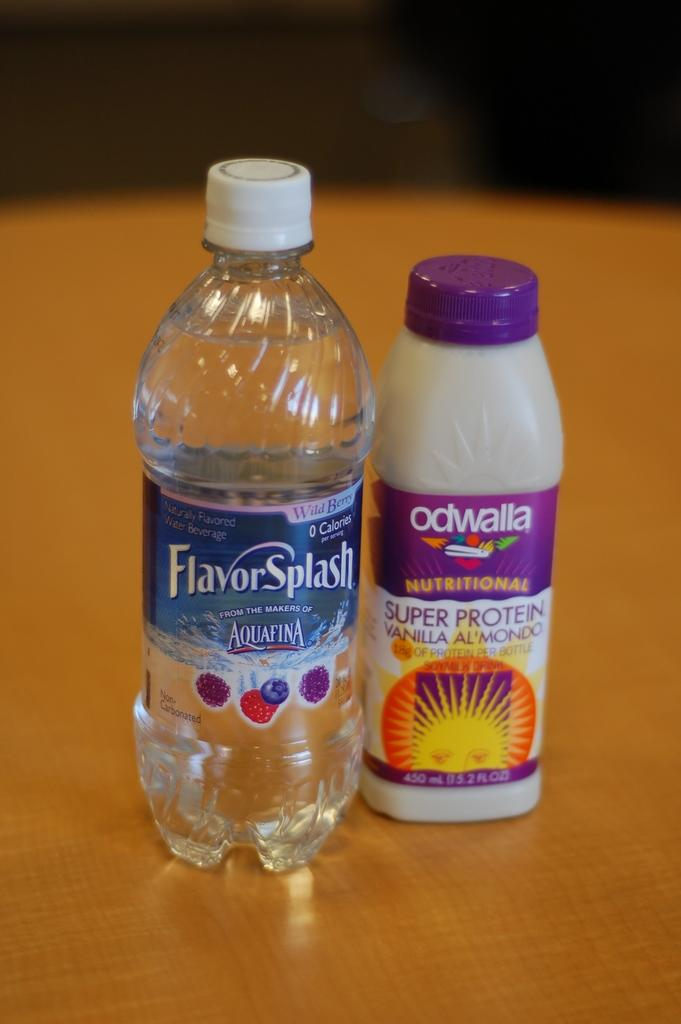<image>
Write a terse but informative summary of the picture. A bottle of Aquafina water bottle is sitting next to Odwalla protein drink. 